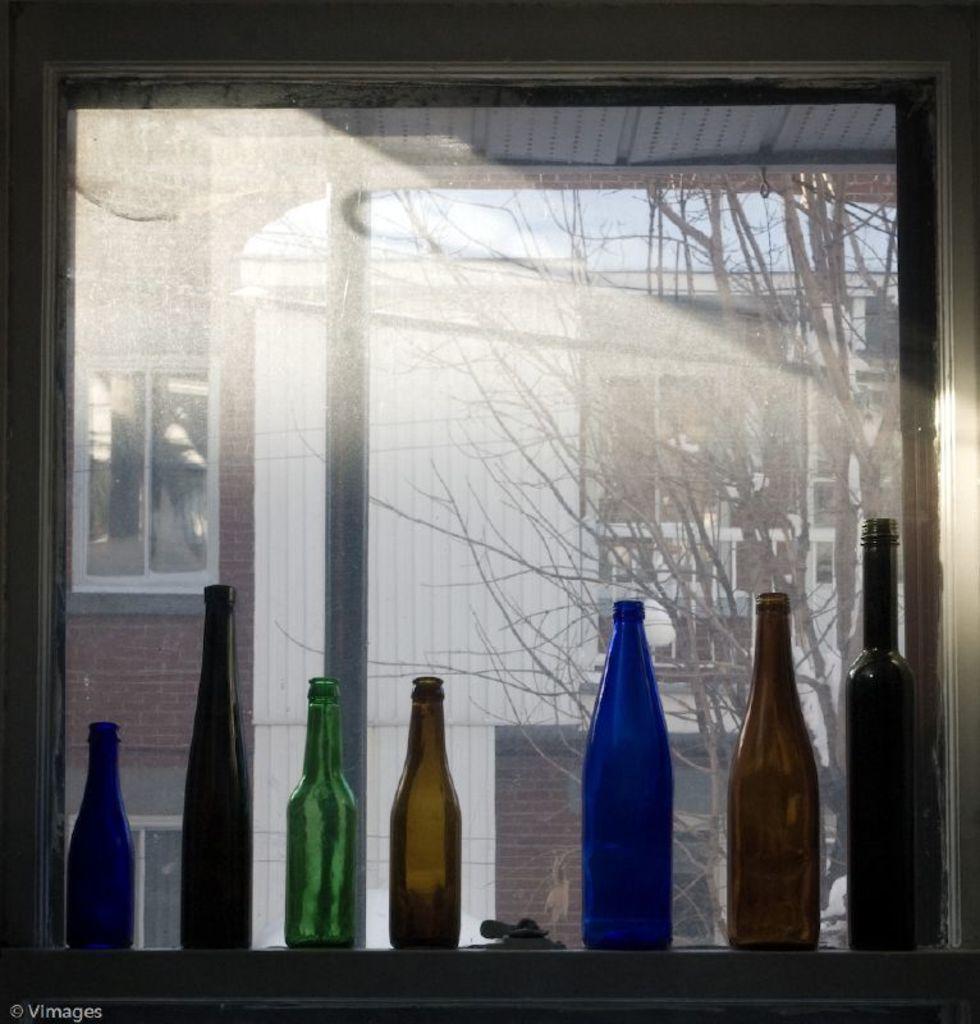How would you summarize this image in a sentence or two? Near this window there are bottles. From this window we can able to see a building and bare tree. 